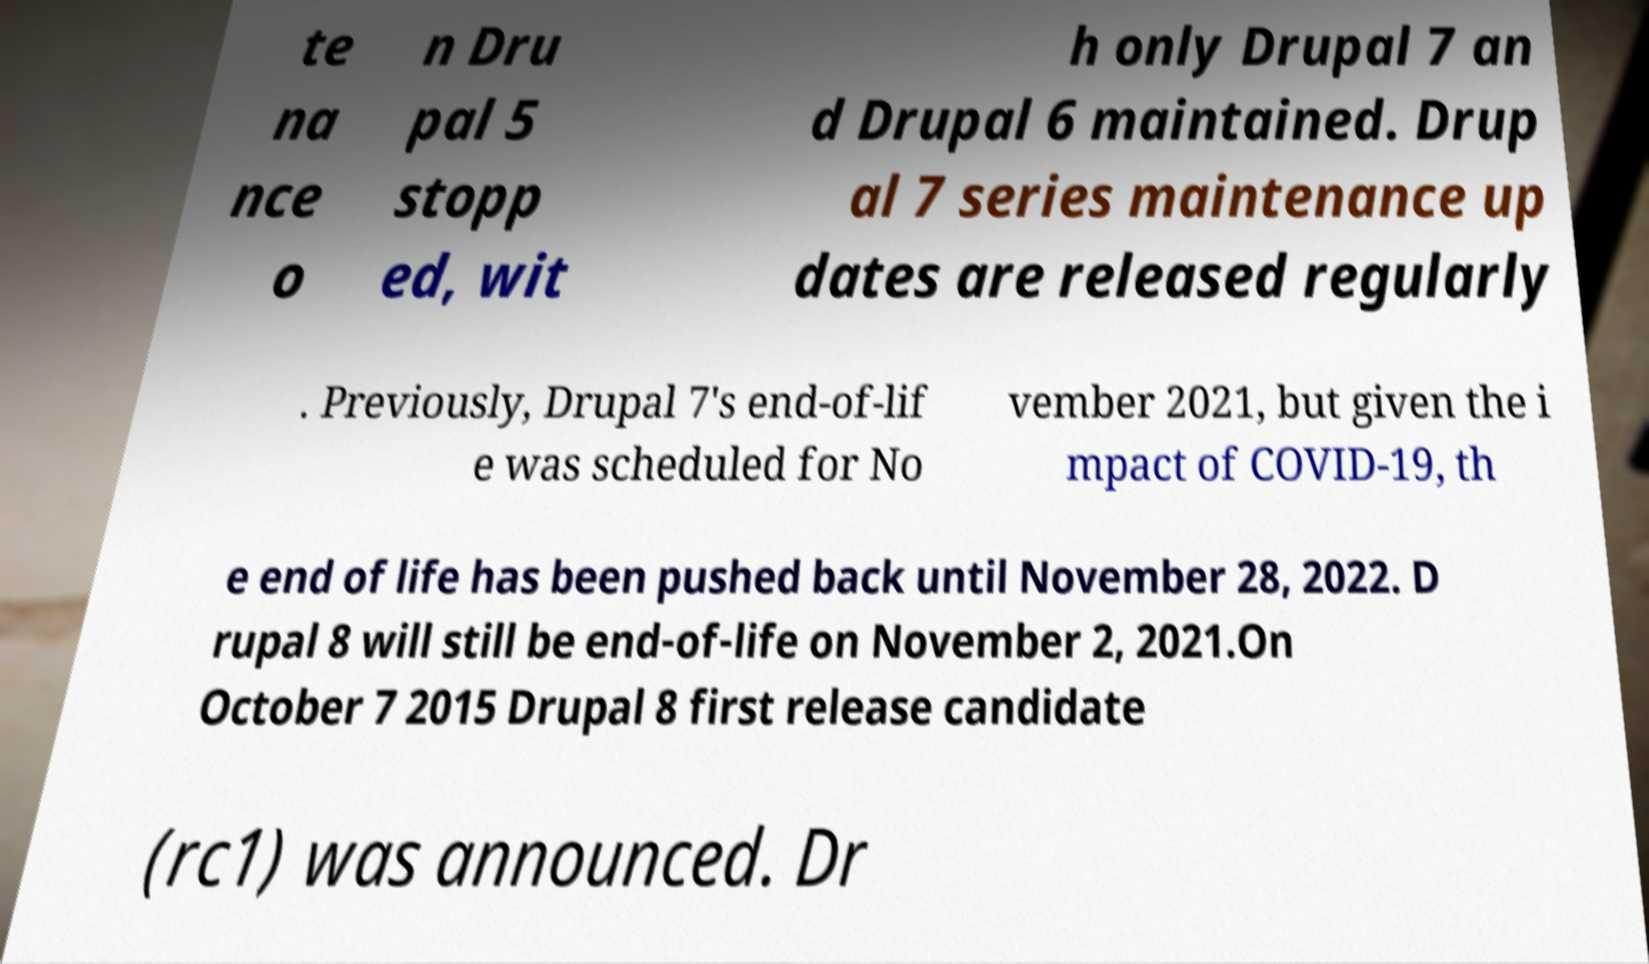There's text embedded in this image that I need extracted. Can you transcribe it verbatim? te na nce o n Dru pal 5 stopp ed, wit h only Drupal 7 an d Drupal 6 maintained. Drup al 7 series maintenance up dates are released regularly . Previously, Drupal 7's end-of-lif e was scheduled for No vember 2021, but given the i mpact of COVID-19, th e end of life has been pushed back until November 28, 2022. D rupal 8 will still be end-of-life on November 2, 2021.On October 7 2015 Drupal 8 first release candidate (rc1) was announced. Dr 